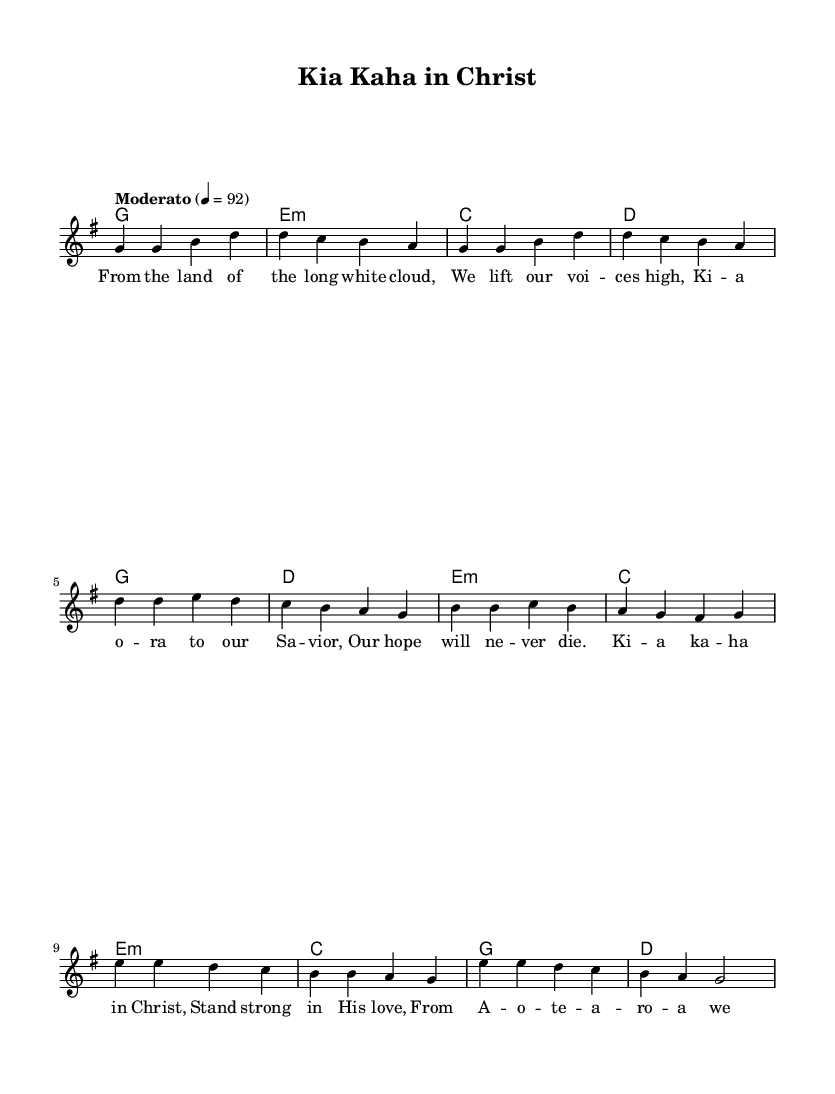What is the key signature of this music? The key signature is G major, which has one sharp (F#). This can be observed in the header section of the sheet music where it specifies "\key g \major".
Answer: G major What is the time signature of this music? The time signature is 4/4, which indicates that there are four beats in a measure and a quarter note gets one beat. This is stated in the header section of the music which includes "\time 4/4".
Answer: 4/4 What is the tempo marking for this piece? The tempo marking is "Moderato," which suggests a moderate speed. This can be confirmed by looking at the tempo instruction in the global section of the music where it states "\tempo 'Moderato' 4 = 92".
Answer: Moderato How many sections does the song have based on the structure? The song has three main sections: a verse, a chorus, and a bridge. Each section is indicated in the melody and the different lyrics that are sung. The verse is first, followed by the chorus, and then the bridge.
Answer: Three What is the first lyric of the verse? The first lyric of the verse is "From the land of the long white cloud," which is found in the verse_lyrics section. This signifies the beginning of the song.
Answer: From the land of the long white cloud What is the last lyric of the bridge? The last lyric of the bridge is "His love brings us peace." This is the concluding line of the bridge_lyrics section, indicating the end of this part of the song.
Answer: His love brings us peace What is the repeated phrase in the chorus? The repeated phrase in the chorus is "Ki a kaha in Christ." This can be seen clearly in the chorus_lyrics where it is the leading line.
Answer: Ki a kaha in Christ 